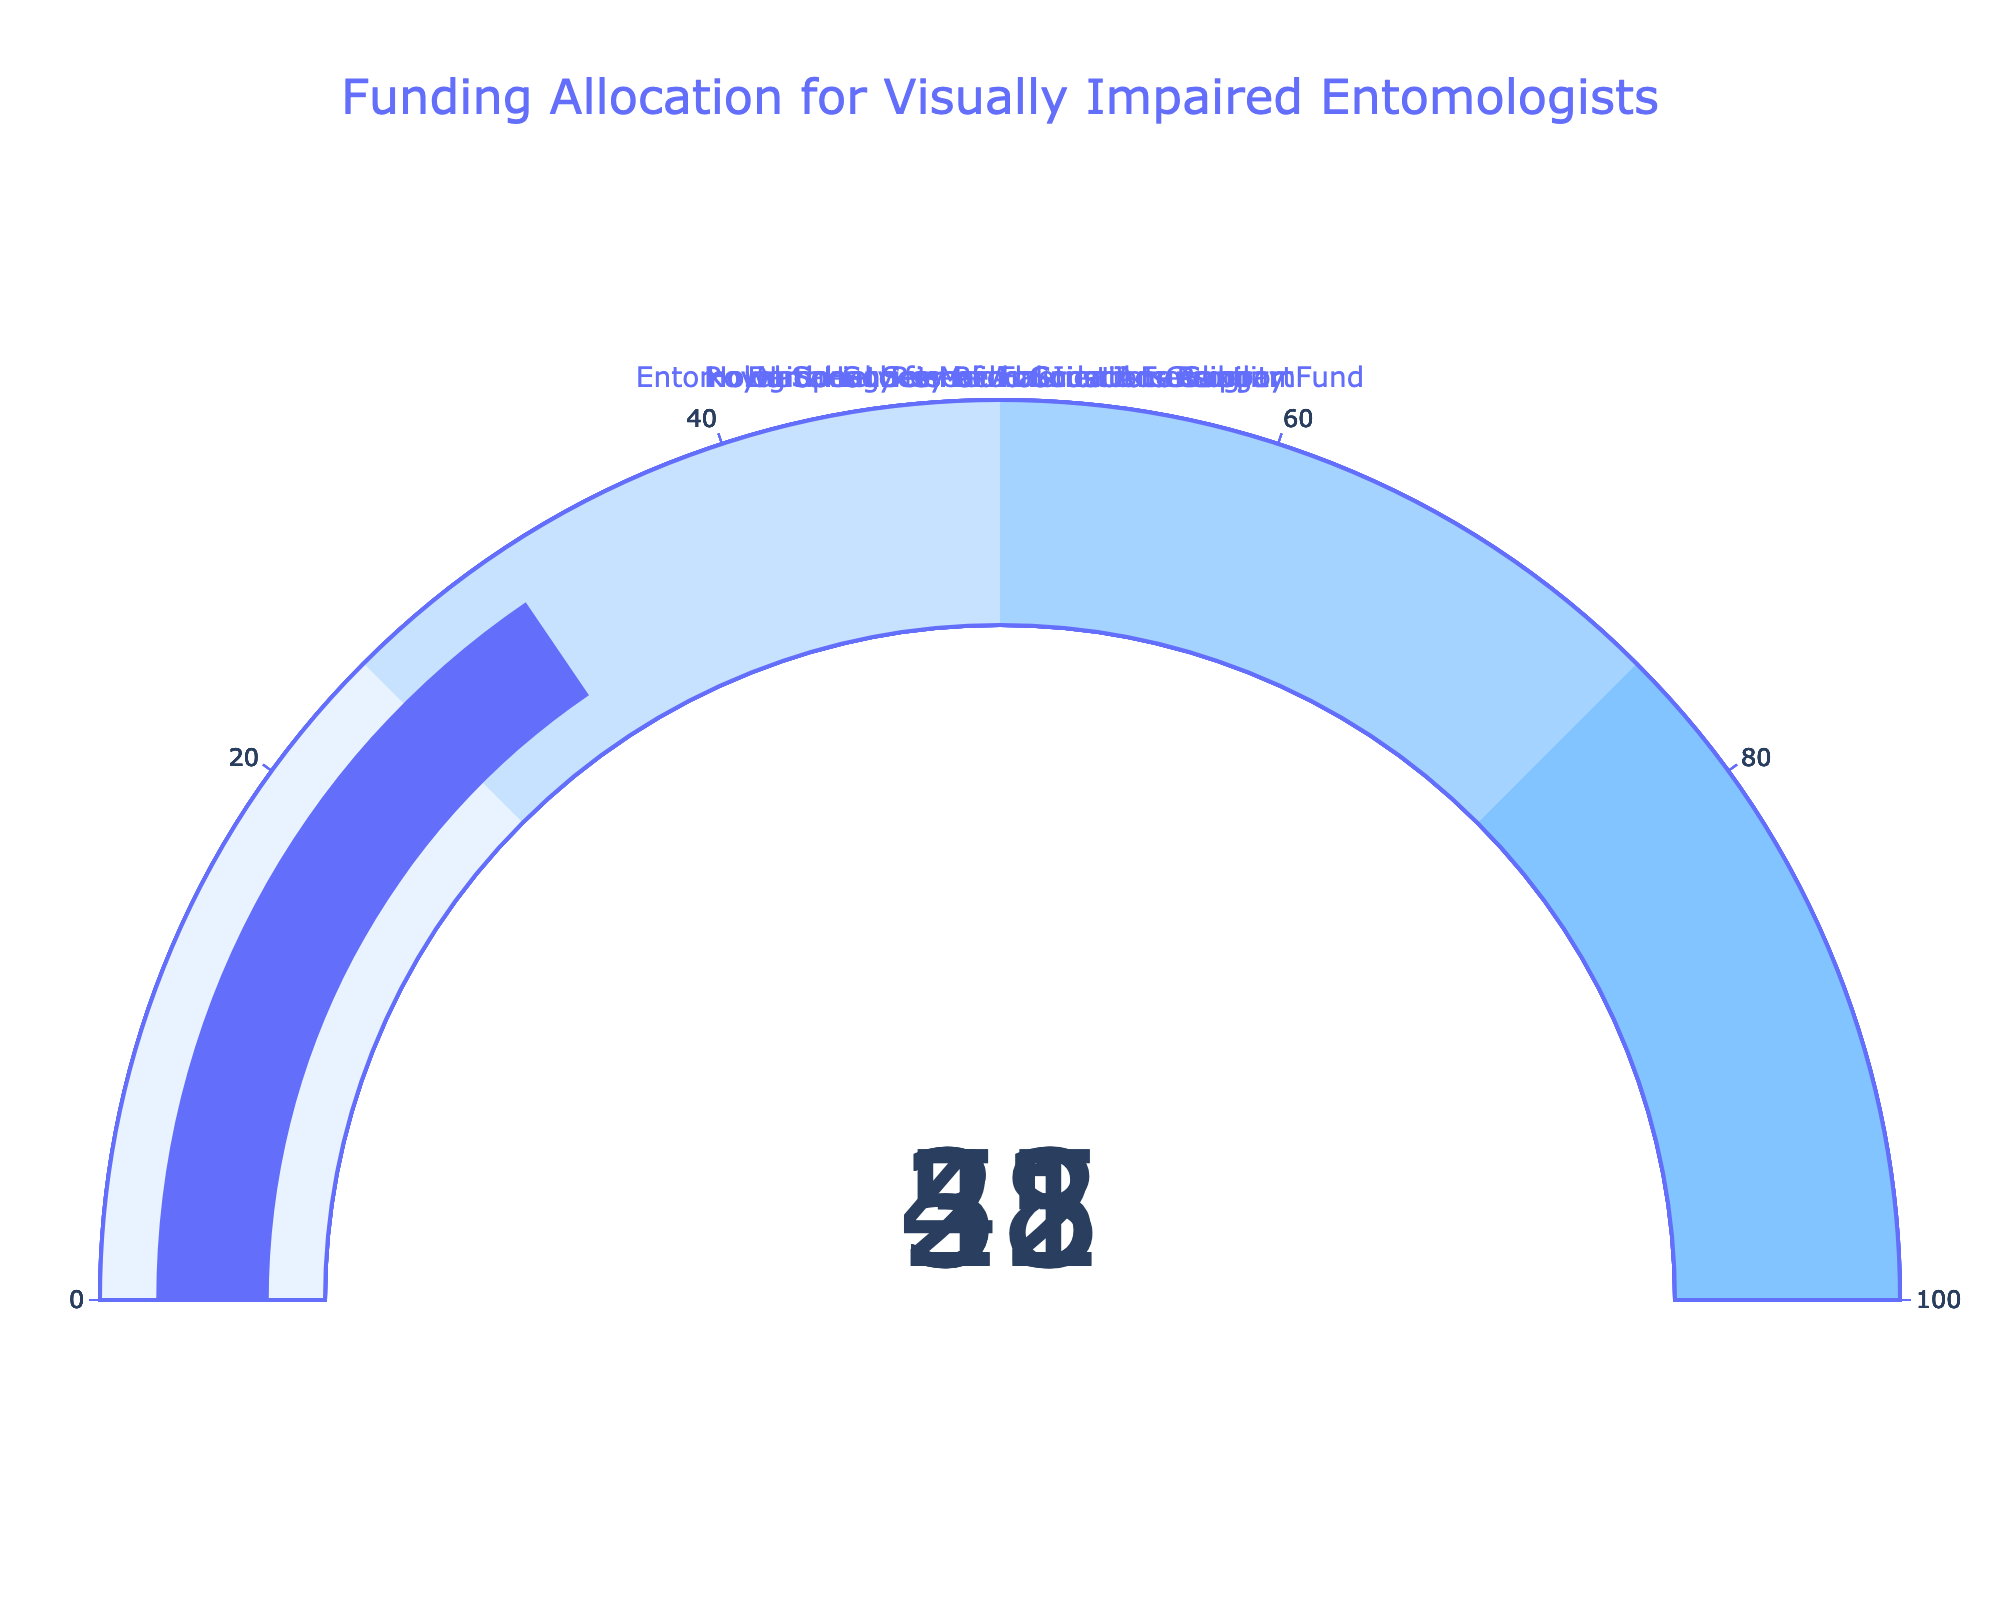What percentage of funding is allocated by the Royal Society for Blind Scientists Program? The gauge chart for the Royal Society for Blind Scientists Program shows the funding percentage. The gauge reads 53%.
Answer: 53 How many categories show a funding allocation of more than 30%? By checking each gauge, we can see the following allocations: National Science Foundation Grant (42), European Research Council Funding (35), Howard Hughes Medical Institute Support (28), Royal Society for Blind Scientists Program (53), Entomological Society of America Accessibility Fund (31). Four categories have more than 30%.
Answer: 4 Which category has the lowest percentage of funding allocated? By examining all gauges, the category with the lowest percentage is Howard Hughes Medical Institute Support, which shows 28%.
Answer: Howard Hughes Medical Institute Support What is the average percentage of funding allocated across all categories? Sum up all the percentages: 42 (NSF) + 35 (ERC) + 28 (HHMI) + 53 (RSB) + 31 (ESA) = 189. Then divide by the number of categories, which is 5. The average is 189 / 5 = 37.8.
Answer: 37.8 Which category has a funding percentage closest to the average allocation? The average allocation is 37.8%. Compare each category's percentage: NSF (42), ERC (35), HHMI (28), RSB (53), ESA (31). The European Research Council Funding, with 35%, is closest to 37.8%.
Answer: European Research Council Funding Does the Entomological Society of America Accessibility Fund have a higher or lower percentage than the European Research Council Funding? Compare the percentages: Entomological Society of America Accessibility Fund has 31%, European Research Council Funding has 35%. The Entomological Society of America Accessibility Fund has a lower percentage.
Answer: Lower What is the total percentage of funding from the National Science Foundation Grant and the Royal Society for Blind Scientists Program combined? Add the percentages of the National Science Foundation Grant (42%) and the Royal Society for Blind Scientists Program (53%). 42 + 53 = 95.
Answer: 95 What is the difference in funding percentage between the category with the highest allocation and the category with the lowest allocation? Subtract the lowest percentage (Howard Hughes Medical Institute Support 28%) from the highest (Royal Society for Blind Scientists Program 53%). 53 - 28 = 25.
Answer: 25 